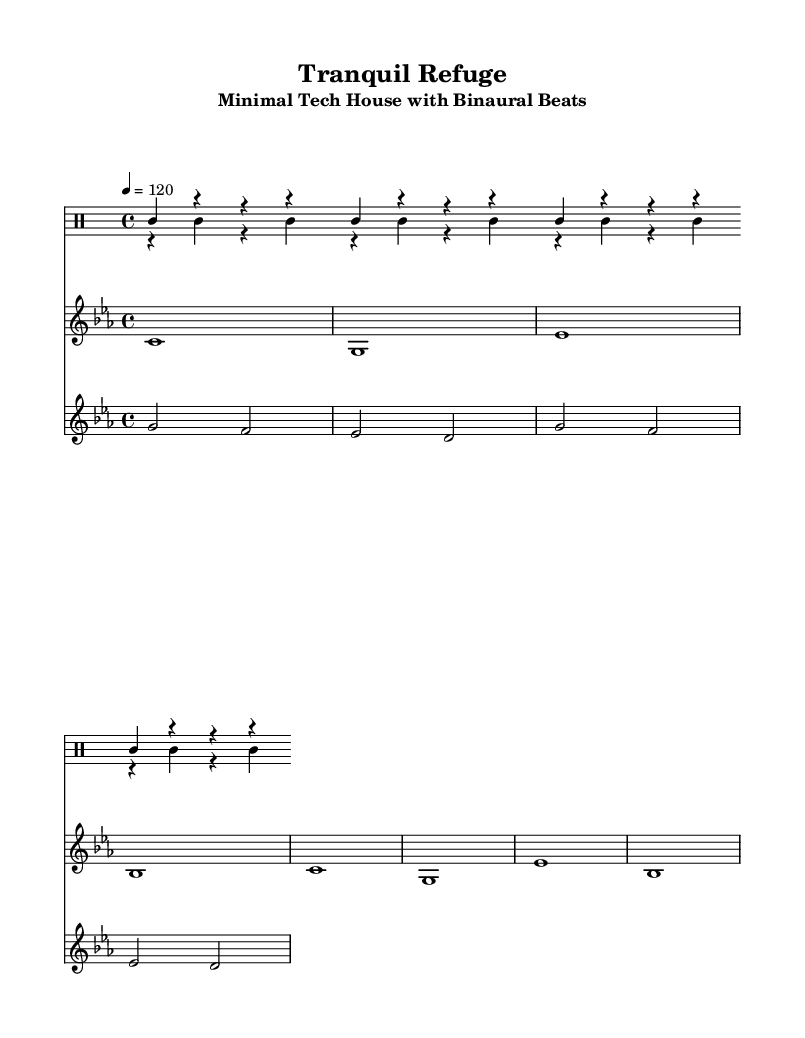What is the key signature of this music? The key signature is C minor, which has three flats: B flat, E flat, and A flat. This is determined by looking at the key indication at the beginning of the staff.
Answer: C minor What is the time signature of this music? The time signature is 4/4, shown at the beginning of the score, indicating that there are four beats per measure and the quarter note gets one beat.
Answer: 4/4 What is the tempo marking for this piece? The tempo marking is indicated as 120 beats per minute, which means the piece should be played at a moderate speed. This is found next to the tempo indication in the score.
Answer: 120 How many measures are there in the kick drum part? The kick drum part contains 4 measures, as indicated by the number of repeated sections shown. Each repetition corresponds to a measure, and there are 4 repeats.
Answer: 4 What type of synth is used for the background atmosphere? The atmospheric synth consists of two-note chords (specifically, half notes) that create a lush sound, forming a harmonic background for the other instruments. This is seen in the staff section labeled atmospheric synth.
Answer: atmospheric synth Does the hi-hat play on off-beats or on-beats? The hi-hat plays on off-beats, hitting on the second and fourth counts of each measure, which is evident in its rhythmic pattern against the kick drum.
Answer: off-beats 